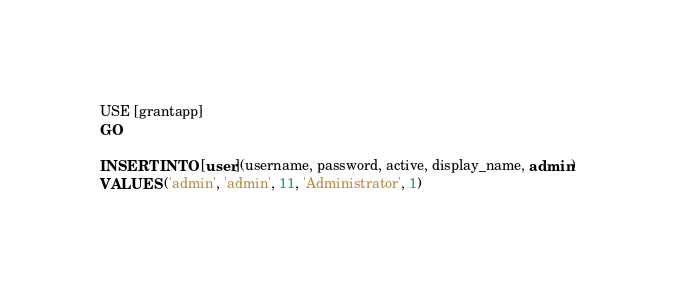<code> <loc_0><loc_0><loc_500><loc_500><_SQL_>USE [grantapp]
GO

INSERT INTO [user](username, password, active, display_name, admin)
VALUES ('admin', 'admin', 11, 'Administrator', 1)
</code> 